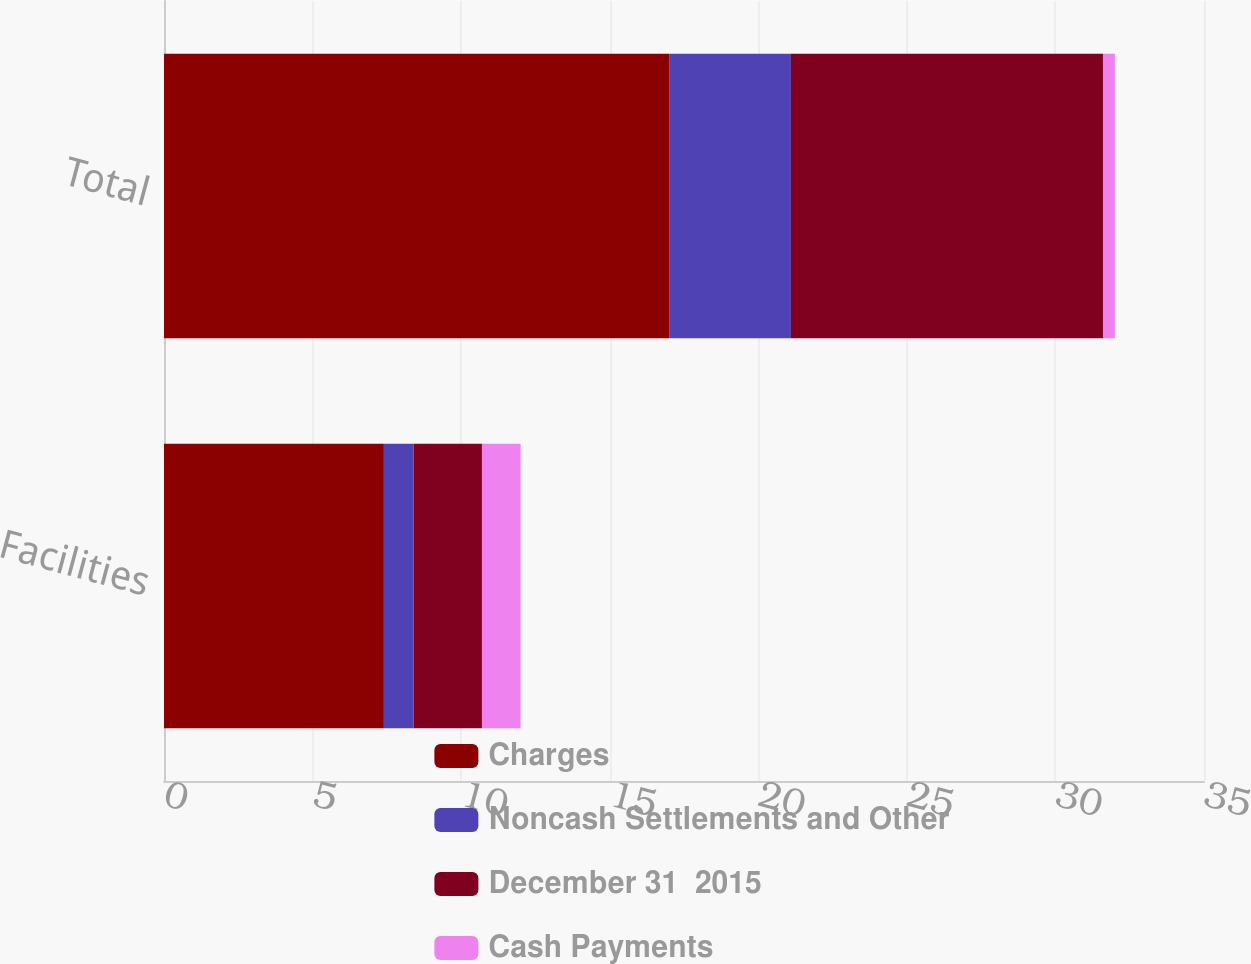<chart> <loc_0><loc_0><loc_500><loc_500><stacked_bar_chart><ecel><fcel>Facilities<fcel>Total<nl><fcel>Charges<fcel>7.4<fcel>17<nl><fcel>Noncash Settlements and Other<fcel>1<fcel>4.1<nl><fcel>December 31  2015<fcel>2.3<fcel>10.5<nl><fcel>Cash Payments<fcel>1.3<fcel>0.4<nl></chart> 